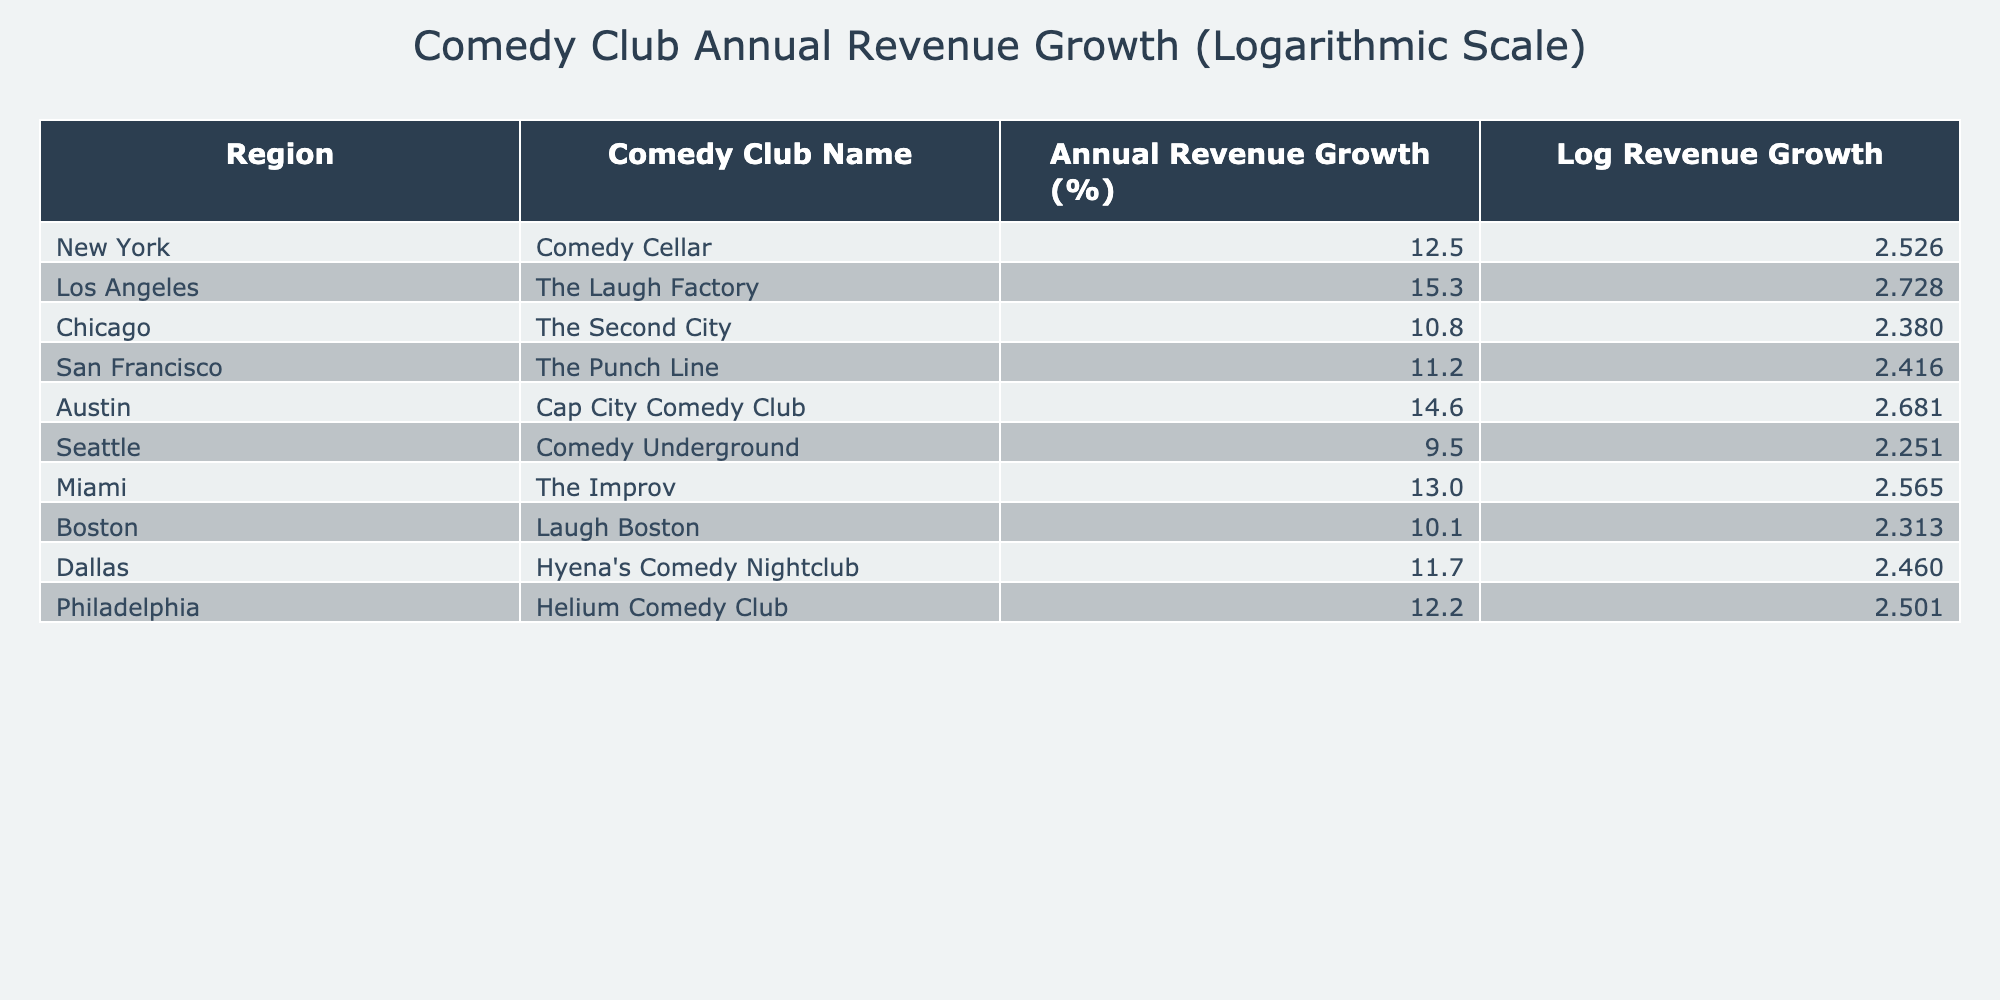What is the highest annual revenue growth percentage in the table? The table lists the annual revenue growth percentages for various comedy clubs. By checking the values, the highest percentage is 15.3, which belongs to The Laugh Factory in Los Angeles.
Answer: 15.3 Which comedy club in New York has an annual revenue growth percentage? The table shows that the Comedy Cellar is the comedy club listed for New York with an annual revenue growth of 12.5%.
Answer: 12.5 What is the average annual revenue growth percentage of the comedy clubs listed in the table? To find the average, we sum all the growth percentages: 12.5 + 15.3 + 10.8 + 11.2 + 14.6 + 9.5 + 13.0 + 10.1 + 11.7 + 12.2 =  131.9. Then, we divide by the number of clubs, which is 10: 131.9 / 10 = 13.19.
Answer: 13.19 Is Comedy Underground's annual revenue growth above 10%? The table shows that Comedy Underground in Seattle has an annual revenue growth of 9.5%. Since 9.5% is below 10%, the answer is no.
Answer: No Which region has the lowest annual revenue growth percentage? By examining the percentages listed, Comedy Underground in Seattle has the lowest growth at 9.5%. Therefore, the region with the lowest growth is Seattle.
Answer: Seattle 